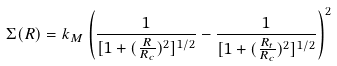Convert formula to latex. <formula><loc_0><loc_0><loc_500><loc_500>\Sigma ( R ) = k _ { M } \left ( \frac { 1 } { [ 1 + ( \frac { R } { R _ { c } } ) ^ { 2 } ] ^ { 1 / 2 } } - \frac { 1 } { [ 1 + ( \frac { R _ { t } } { R _ { c } } ) ^ { 2 } ] ^ { 1 / 2 } } \right ) ^ { 2 }</formula> 